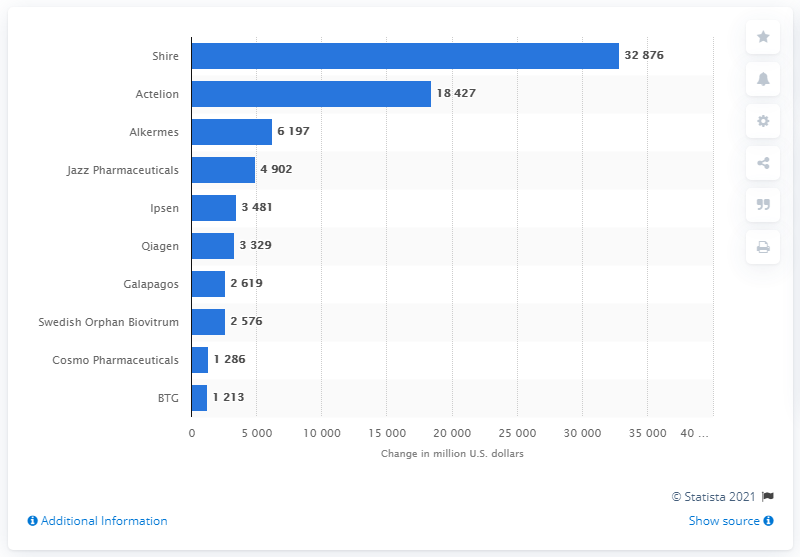Identify some key points in this picture. The average market capitalization of companies with a market capitalization under $200,000,000 is 1249.5. The third longest bar value is Alkermes. During the period of 2012 to 2016, Jazz Pharmaceuticals' market capitalization was 32,876... 